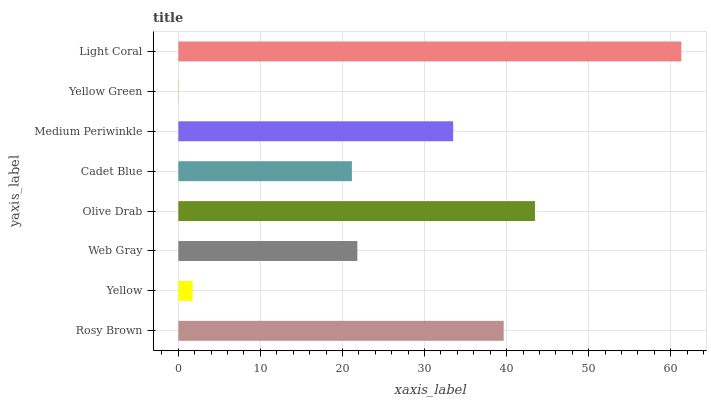Is Yellow Green the minimum?
Answer yes or no. Yes. Is Light Coral the maximum?
Answer yes or no. Yes. Is Yellow the minimum?
Answer yes or no. No. Is Yellow the maximum?
Answer yes or no. No. Is Rosy Brown greater than Yellow?
Answer yes or no. Yes. Is Yellow less than Rosy Brown?
Answer yes or no. Yes. Is Yellow greater than Rosy Brown?
Answer yes or no. No. Is Rosy Brown less than Yellow?
Answer yes or no. No. Is Medium Periwinkle the high median?
Answer yes or no. Yes. Is Web Gray the low median?
Answer yes or no. Yes. Is Web Gray the high median?
Answer yes or no. No. Is Yellow the low median?
Answer yes or no. No. 